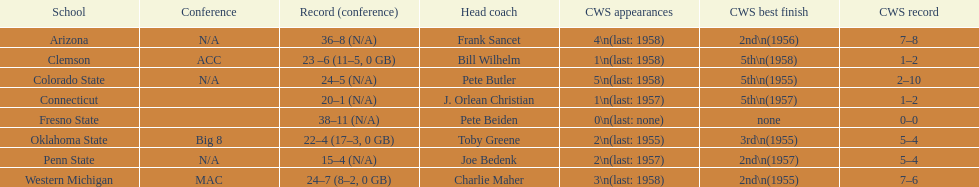Can you name the schools that had the worst rankings in the cws best finish? Clemson, Colorado State, Connecticut. 